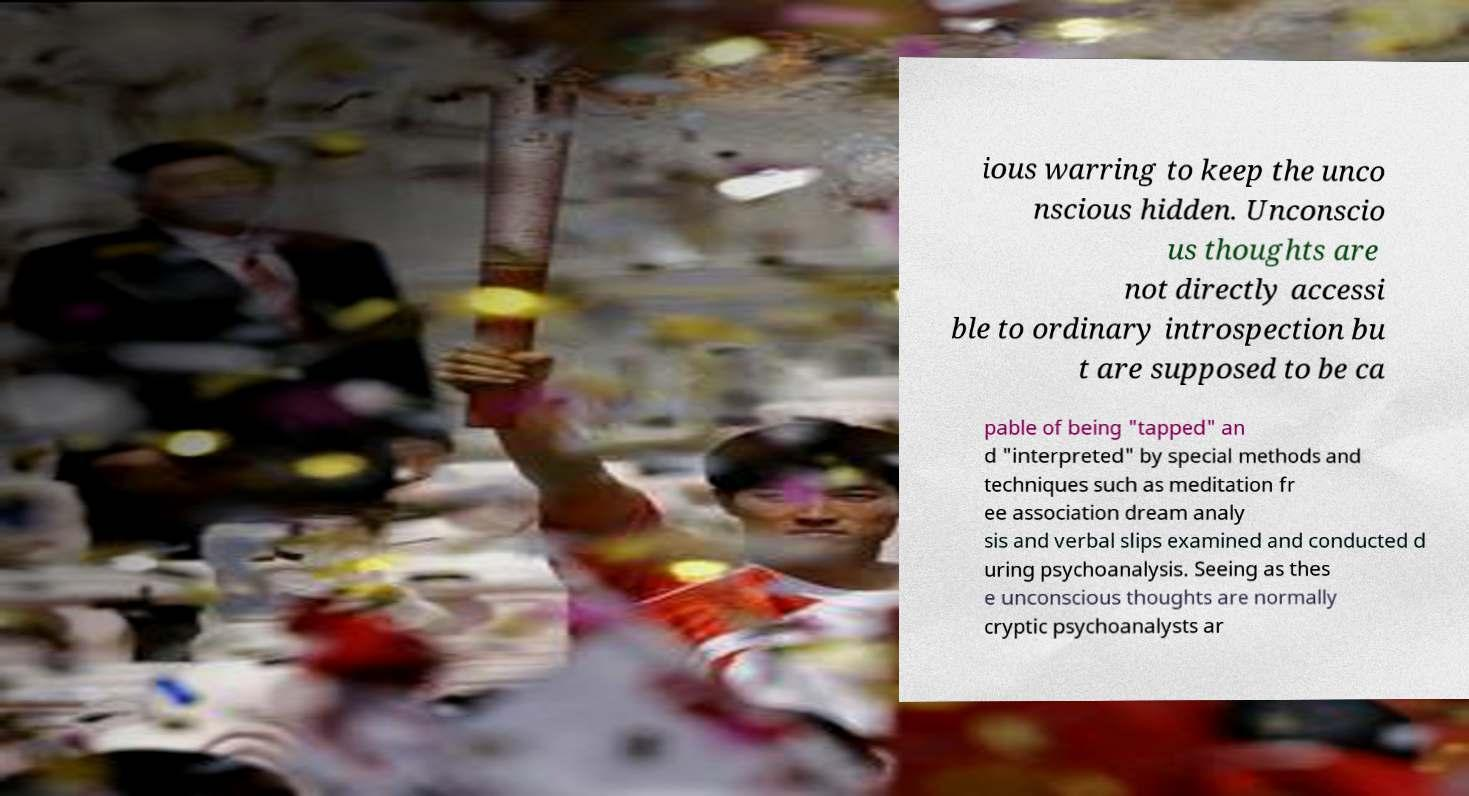What messages or text are displayed in this image? I need them in a readable, typed format. ious warring to keep the unco nscious hidden. Unconscio us thoughts are not directly accessi ble to ordinary introspection bu t are supposed to be ca pable of being "tapped" an d "interpreted" by special methods and techniques such as meditation fr ee association dream analy sis and verbal slips examined and conducted d uring psychoanalysis. Seeing as thes e unconscious thoughts are normally cryptic psychoanalysts ar 